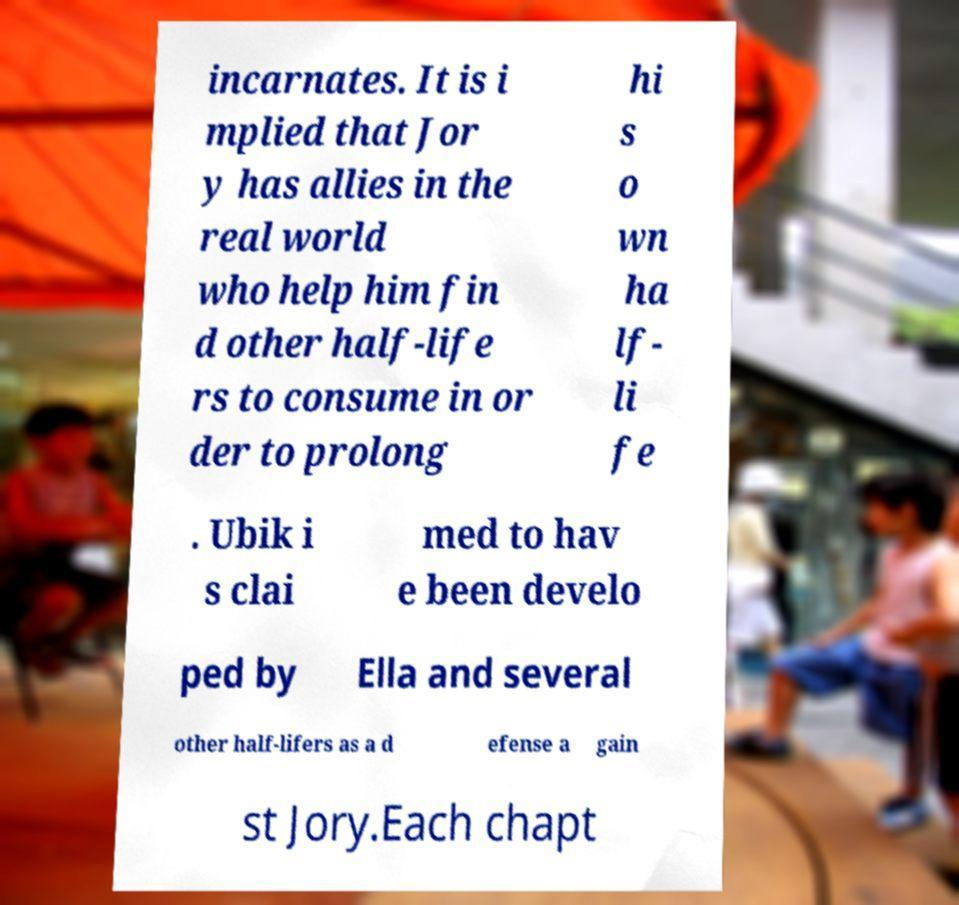Could you extract and type out the text from this image? incarnates. It is i mplied that Jor y has allies in the real world who help him fin d other half-life rs to consume in or der to prolong hi s o wn ha lf- li fe . Ubik i s clai med to hav e been develo ped by Ella and several other half-lifers as a d efense a gain st Jory.Each chapt 